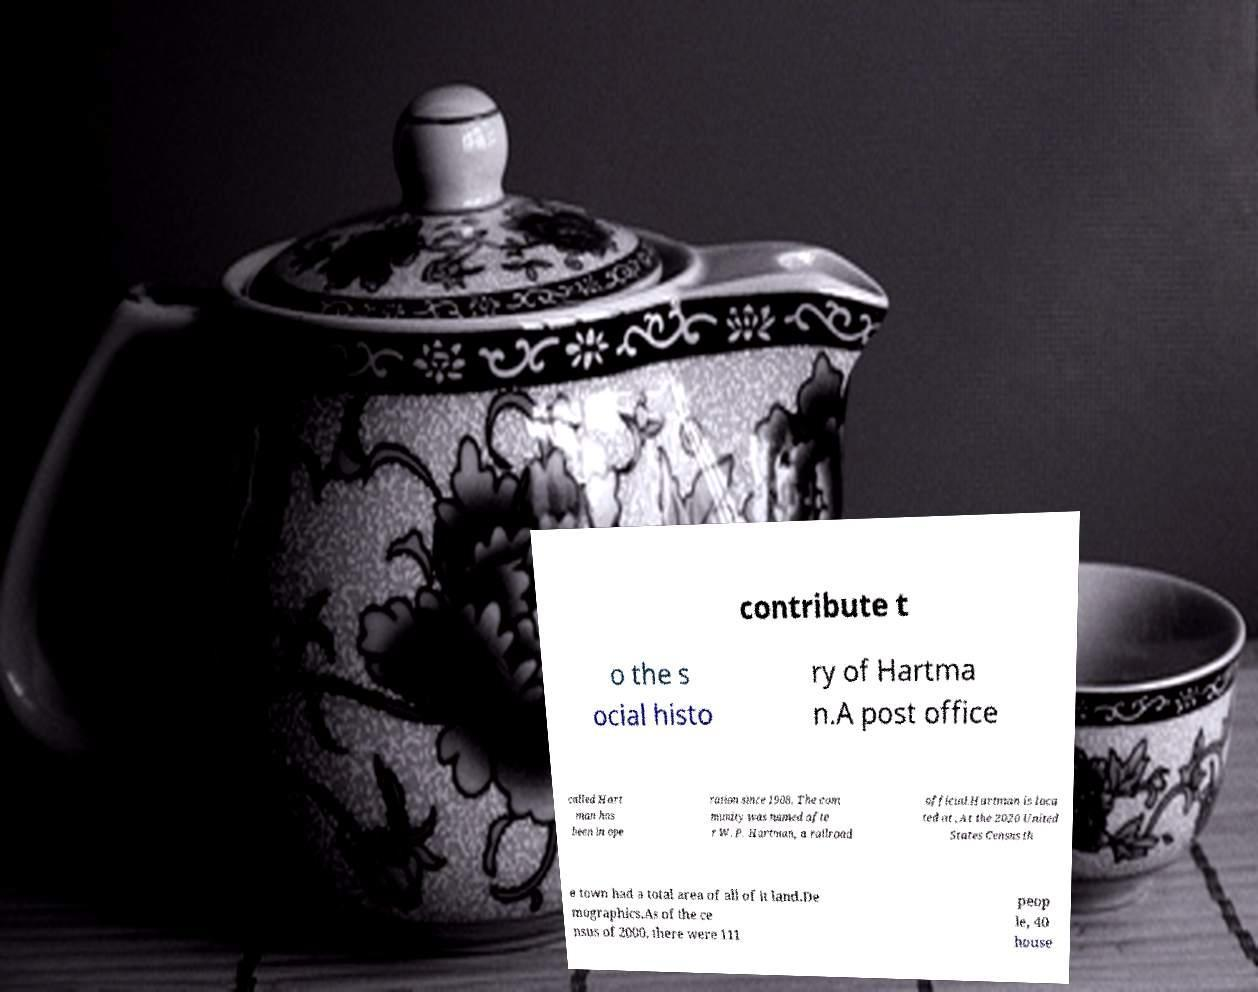There's text embedded in this image that I need extracted. Can you transcribe it verbatim? contribute t o the s ocial histo ry of Hartma n.A post office called Hart man has been in ope ration since 1908. The com munity was named afte r W. P. Hartman, a railroad official.Hartman is loca ted at ,At the 2020 United States Census th e town had a total area of all of it land.De mographics.As of the ce nsus of 2000, there were 111 peop le, 40 house 